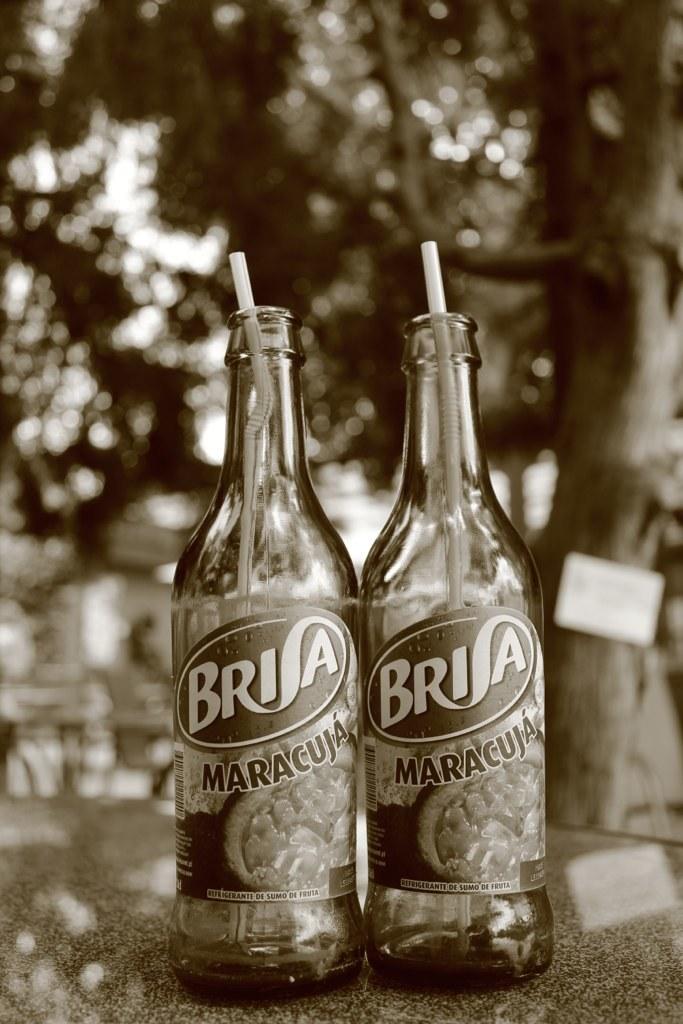What brand does maracuja belong to?
Offer a very short reply. Brisa. 